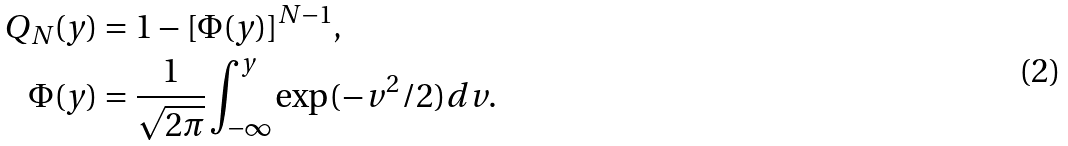<formula> <loc_0><loc_0><loc_500><loc_500>Q _ { N } ( y ) & = 1 - [ \Phi ( y ) ] ^ { N - 1 } , \\ \Phi ( y ) & = \frac { 1 } { \sqrt { 2 \pi } } \int _ { - \infty } ^ { y } \exp ( - v ^ { 2 } / 2 ) d v .</formula> 